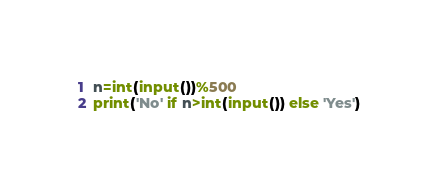Convert code to text. <code><loc_0><loc_0><loc_500><loc_500><_Python_>n=int(input())%500
print('No' if n>int(input()) else 'Yes')</code> 